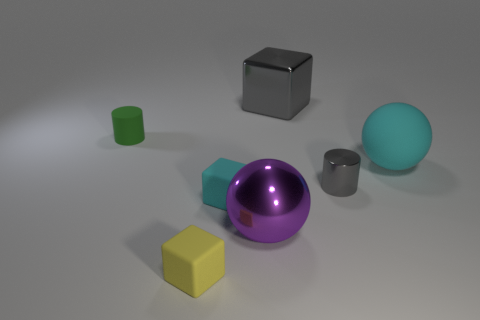The big ball in front of the large sphere behind the small metal cylinder is what color?
Offer a terse response. Purple. The small thing that is both in front of the big cyan object and behind the cyan rubber block is made of what material?
Ensure brevity in your answer.  Metal. Are there any tiny brown rubber things that have the same shape as the large purple object?
Provide a short and direct response. No. Do the gray thing that is in front of the tiny green rubber thing and the small green object have the same shape?
Your response must be concise. Yes. How many metallic things are in front of the big cyan thing and on the left side of the tiny gray thing?
Your answer should be very brief. 1. There is a big metallic object behind the tiny cyan thing; what is its shape?
Ensure brevity in your answer.  Cube. How many things are the same material as the purple sphere?
Provide a succinct answer. 2. Is the shape of the large gray object the same as the small rubber thing that is right of the small yellow rubber object?
Make the answer very short. Yes. Are there any large cyan matte balls on the right side of the tiny cylinder that is to the right of the small matte thing that is behind the small gray thing?
Keep it short and to the point. Yes. How big is the block that is in front of the small cyan rubber object?
Your answer should be very brief. Small. 